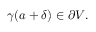Convert formula to latex. <formula><loc_0><loc_0><loc_500><loc_500>\gamma ( a + \delta ) \in \partial V .</formula> 